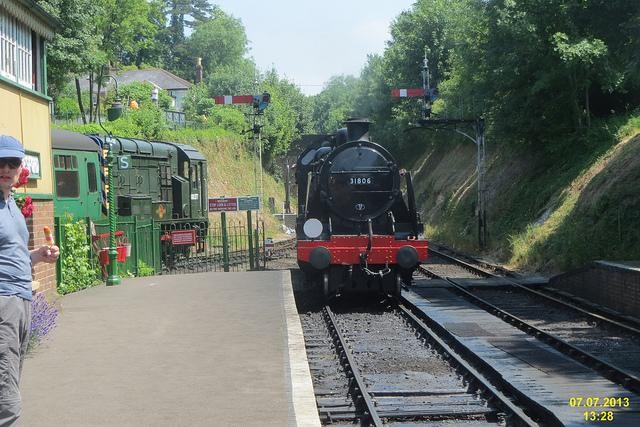What sound do people say the item on the right makes?

Choices:
A) meow
B) moo
C) choo choo
D) woof choo choo 